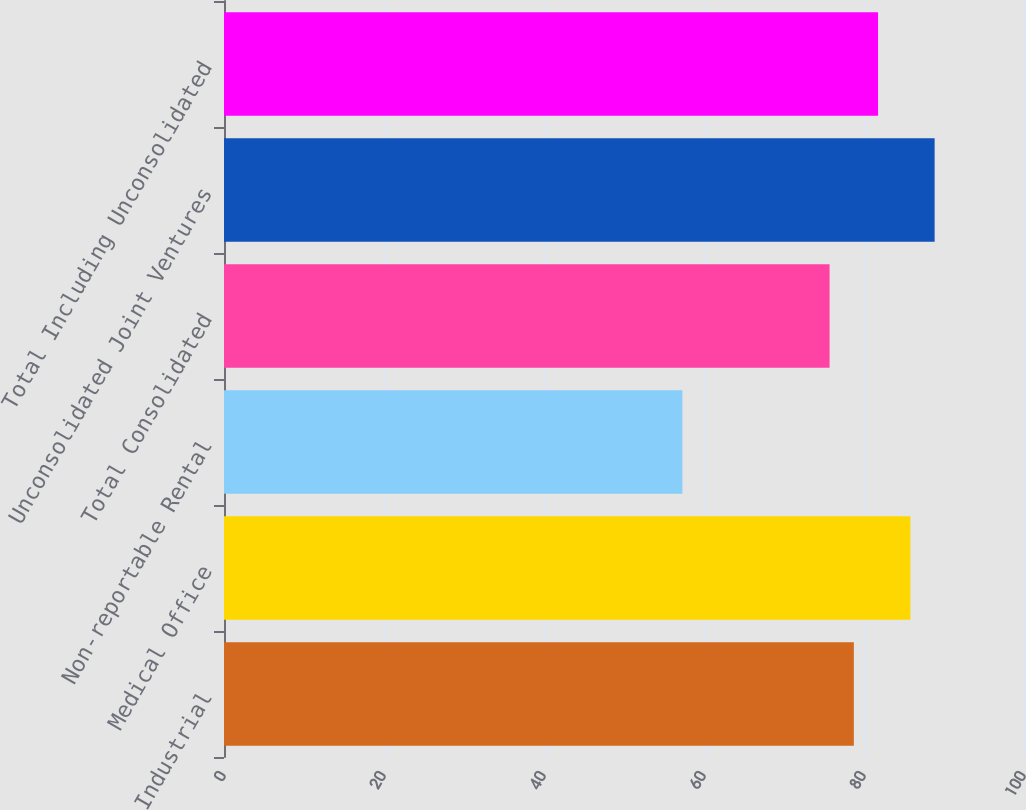Convert chart. <chart><loc_0><loc_0><loc_500><loc_500><bar_chart><fcel>Industrial<fcel>Medical Office<fcel>Non-reportable Rental<fcel>Total Consolidated<fcel>Unconsolidated Joint Ventures<fcel>Total Including Unconsolidated<nl><fcel>78.73<fcel>85.8<fcel>57.3<fcel>75.7<fcel>88.83<fcel>81.76<nl></chart> 